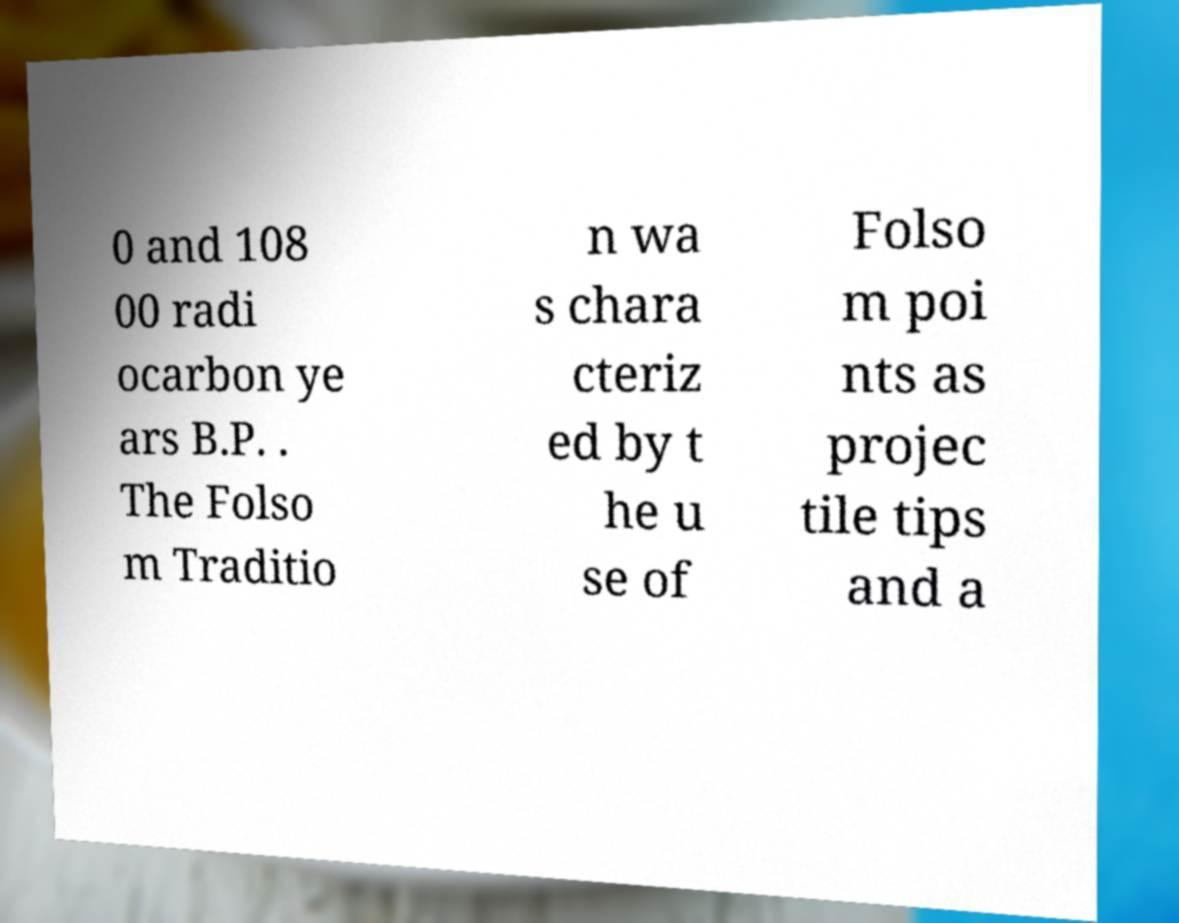There's text embedded in this image that I need extracted. Can you transcribe it verbatim? 0 and 108 00 radi ocarbon ye ars B.P. . The Folso m Traditio n wa s chara cteriz ed by t he u se of Folso m poi nts as projec tile tips and a 